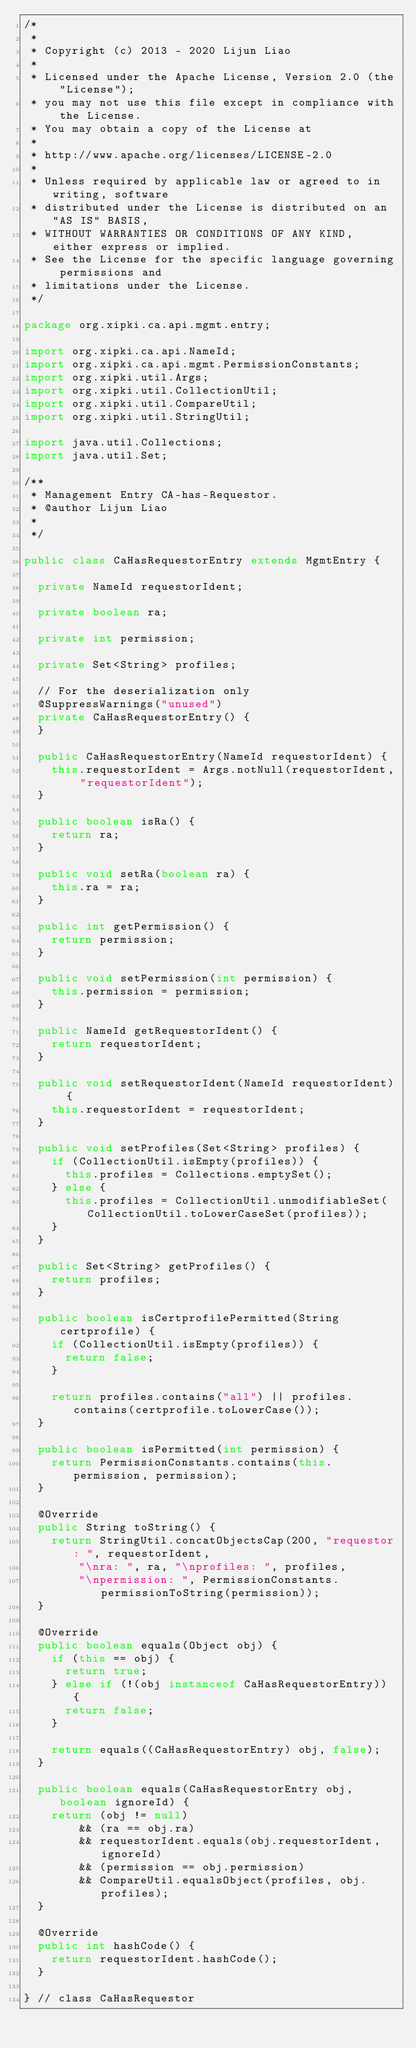<code> <loc_0><loc_0><loc_500><loc_500><_Java_>/*
 *
 * Copyright (c) 2013 - 2020 Lijun Liao
 *
 * Licensed under the Apache License, Version 2.0 (the "License");
 * you may not use this file except in compliance with the License.
 * You may obtain a copy of the License at
 *
 * http://www.apache.org/licenses/LICENSE-2.0
 *
 * Unless required by applicable law or agreed to in writing, software
 * distributed under the License is distributed on an "AS IS" BASIS,
 * WITHOUT WARRANTIES OR CONDITIONS OF ANY KIND, either express or implied.
 * See the License for the specific language governing permissions and
 * limitations under the License.
 */

package org.xipki.ca.api.mgmt.entry;

import org.xipki.ca.api.NameId;
import org.xipki.ca.api.mgmt.PermissionConstants;
import org.xipki.util.Args;
import org.xipki.util.CollectionUtil;
import org.xipki.util.CompareUtil;
import org.xipki.util.StringUtil;

import java.util.Collections;
import java.util.Set;

/**
 * Management Entry CA-has-Requestor.
 * @author Lijun Liao
 *
 */

public class CaHasRequestorEntry extends MgmtEntry {

  private NameId requestorIdent;

  private boolean ra;

  private int permission;

  private Set<String> profiles;

  // For the deserialization only
  @SuppressWarnings("unused")
  private CaHasRequestorEntry() {
  }

  public CaHasRequestorEntry(NameId requestorIdent) {
    this.requestorIdent = Args.notNull(requestorIdent, "requestorIdent");
  }

  public boolean isRa() {
    return ra;
  }

  public void setRa(boolean ra) {
    this.ra = ra;
  }

  public int getPermission() {
    return permission;
  }

  public void setPermission(int permission) {
    this.permission = permission;
  }

  public NameId getRequestorIdent() {
    return requestorIdent;
  }

  public void setRequestorIdent(NameId requestorIdent) {
    this.requestorIdent = requestorIdent;
  }

  public void setProfiles(Set<String> profiles) {
    if (CollectionUtil.isEmpty(profiles)) {
      this.profiles = Collections.emptySet();
    } else {
      this.profiles = CollectionUtil.unmodifiableSet(CollectionUtil.toLowerCaseSet(profiles));
    }
  }

  public Set<String> getProfiles() {
    return profiles;
  }

  public boolean isCertprofilePermitted(String certprofile) {
    if (CollectionUtil.isEmpty(profiles)) {
      return false;
    }

    return profiles.contains("all") || profiles.contains(certprofile.toLowerCase());
  }

  public boolean isPermitted(int permission) {
    return PermissionConstants.contains(this.permission, permission);
  }

  @Override
  public String toString() {
    return StringUtil.concatObjectsCap(200, "requestor: ", requestorIdent,
        "\nra: ", ra, "\nprofiles: ", profiles,
        "\npermission: ", PermissionConstants.permissionToString(permission));
  }

  @Override
  public boolean equals(Object obj) {
    if (this == obj) {
      return true;
    } else if (!(obj instanceof CaHasRequestorEntry)) {
      return false;
    }

    return equals((CaHasRequestorEntry) obj, false);
  }

  public boolean equals(CaHasRequestorEntry obj, boolean ignoreId) {
    return (obj != null)
        && (ra == obj.ra)
        && requestorIdent.equals(obj.requestorIdent, ignoreId)
        && (permission == obj.permission)
        && CompareUtil.equalsObject(profiles, obj.profiles);
  }

  @Override
  public int hashCode() {
    return requestorIdent.hashCode();
  }

} // class CaHasRequestor
</code> 